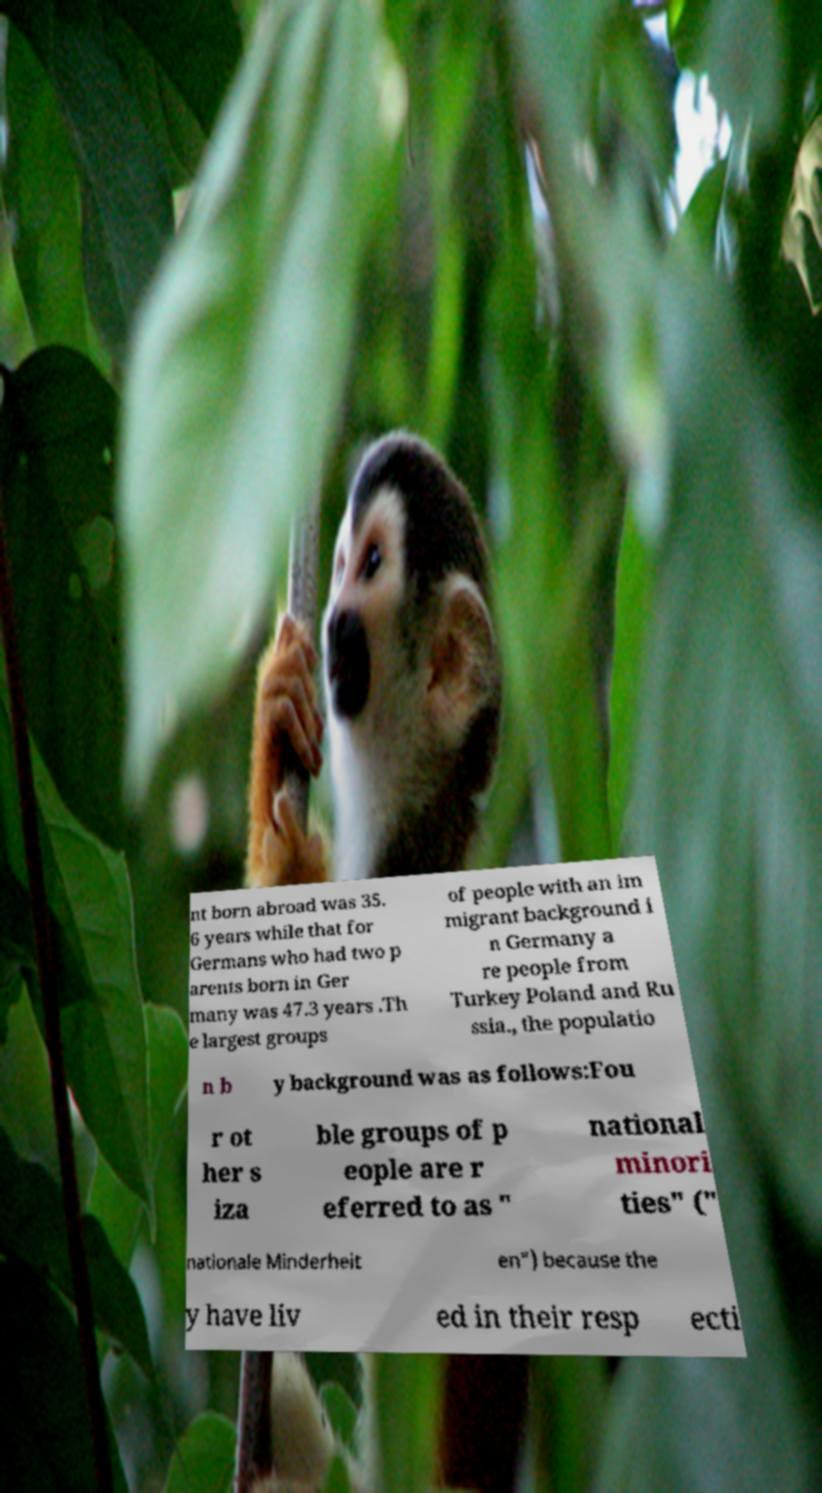I need the written content from this picture converted into text. Can you do that? nt born abroad was 35. 6 years while that for Germans who had two p arents born in Ger many was 47.3 years .Th e largest groups of people with an im migrant background i n Germany a re people from Turkey Poland and Ru ssia., the populatio n b y background was as follows:Fou r ot her s iza ble groups of p eople are r eferred to as " national minori ties" (" nationale Minderheit en") because the y have liv ed in their resp ecti 